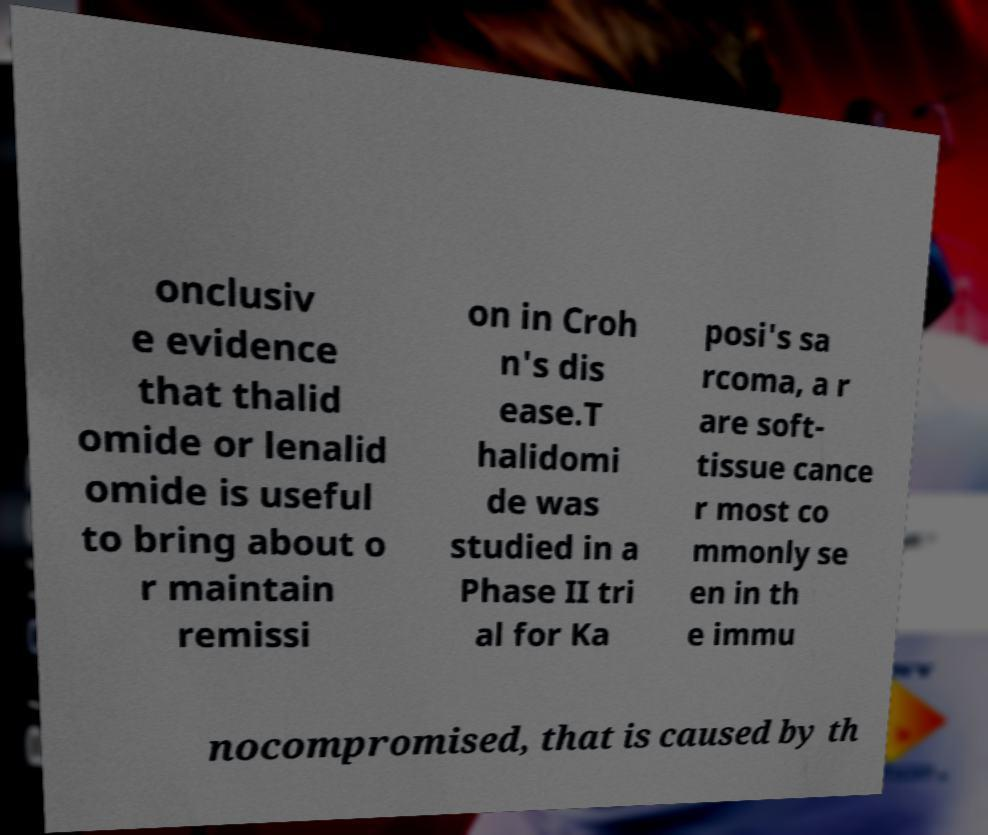There's text embedded in this image that I need extracted. Can you transcribe it verbatim? onclusiv e evidence that thalid omide or lenalid omide is useful to bring about o r maintain remissi on in Croh n's dis ease.T halidomi de was studied in a Phase II tri al for Ka posi's sa rcoma, a r are soft- tissue cance r most co mmonly se en in th e immu nocompromised, that is caused by th 